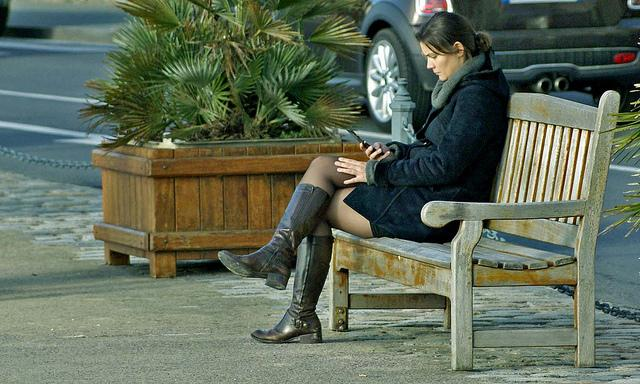What is she doing? texting 